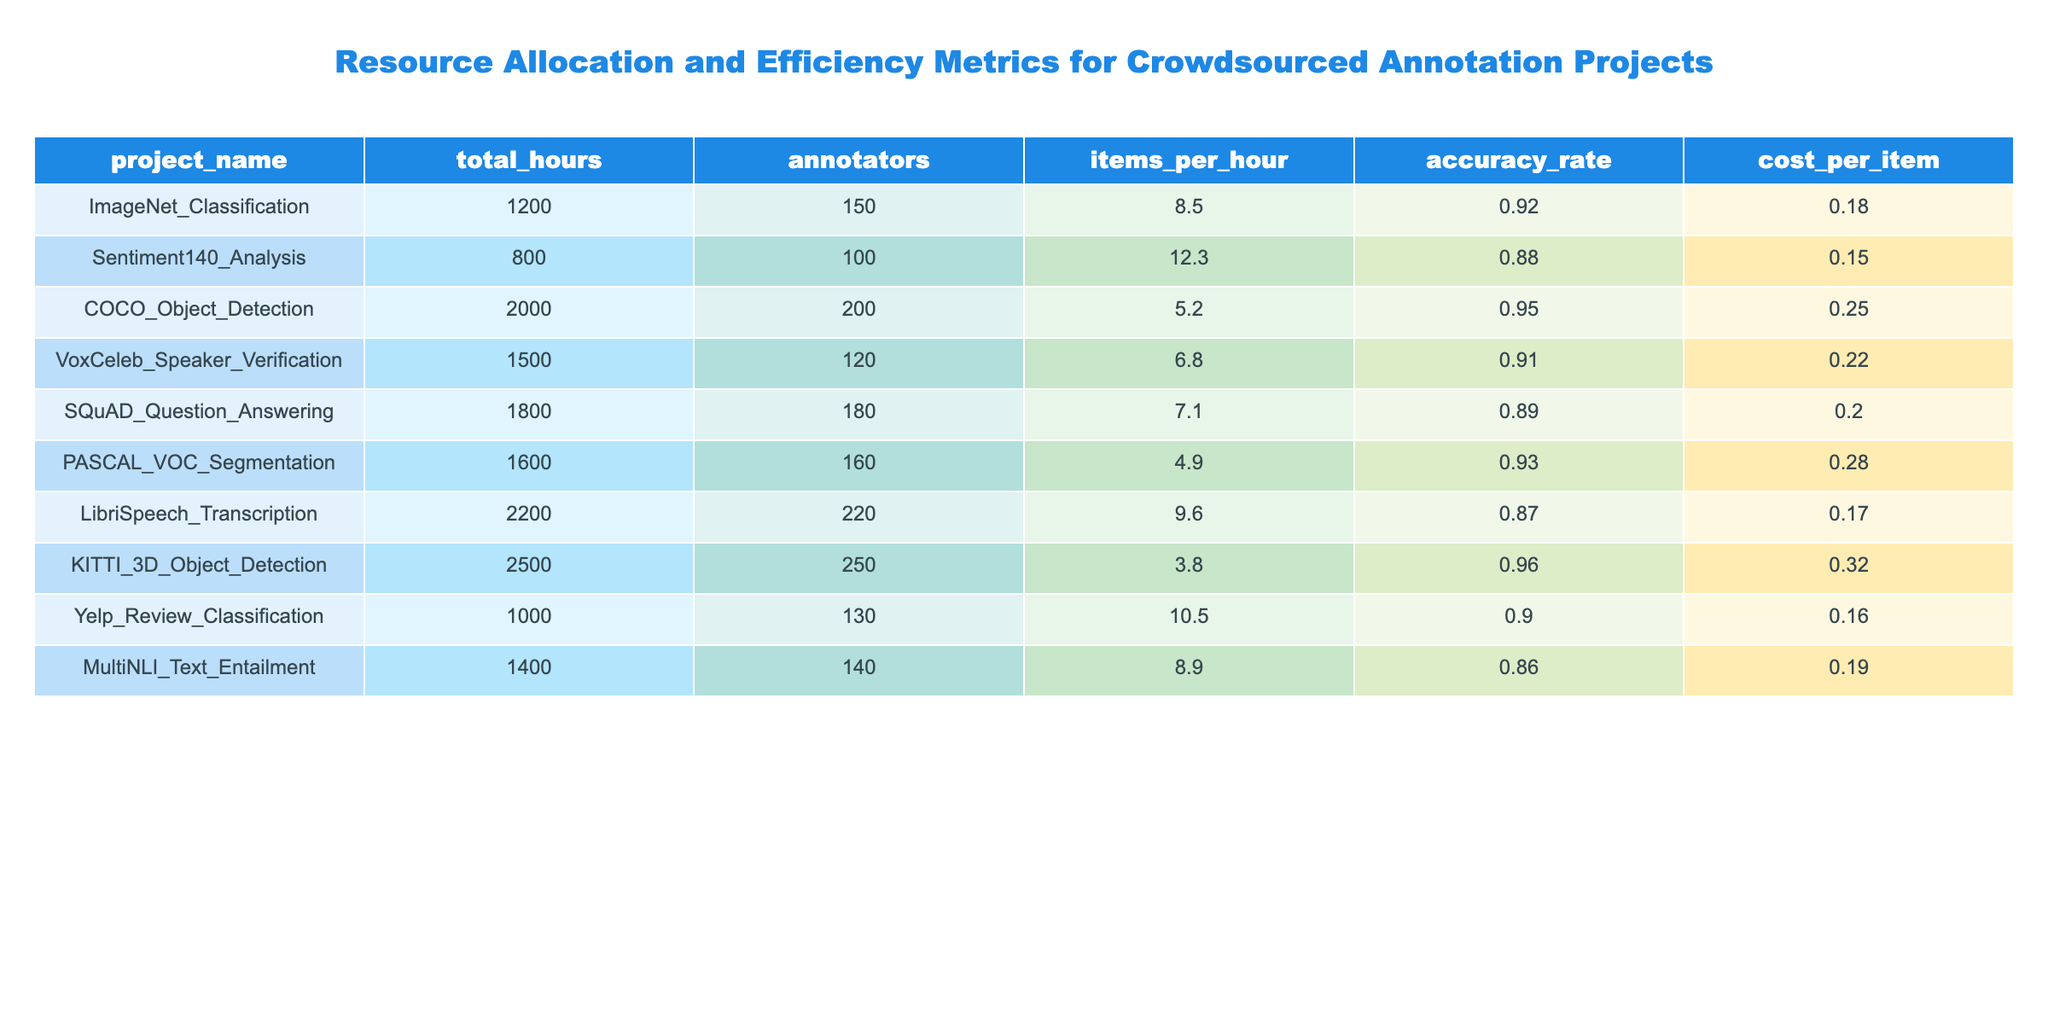What is the total number of annotators for the COCO_Object_Detection project? In the table, the column for annotators shows that COCO_Object_Detection has 200 annotators.
Answer: 200 Which project has the highest accuracy rate? Looking at the accuracy rate column, KITTI_3D_Object_Detection has the highest accuracy at 0.96.
Answer: KITTI_3D_Object_Detection What is the cost per item for the SQuAD_Question_Answering project? By checking the cost_per_item column, we find that SQuAD_Question_Answering costs 0.20 per item.
Answer: 0.20 Calculate the average items processed per hour across all projects. To find the average, sum the items_per_hour for all projects: (8.5 + 12.3 + 5.2 + 6.8 + 7.1 + 4.9 + 9.6 + 3.8 + 10.5 + 8.9) = 67.1; there are 10 projects, so the average is 67.1 / 10 = 6.71.
Answer: 6.71 Which project requires the least total hours? By examining the total_hours column, Sentiment140_Analysis has the lowest total hours at 800.
Answer: Sentiment140_Analysis Is the cost per item for the LibriSpeech_Transcription project lower than the cost per item for the PASCAL_VOC_Segmentation project? The cost per item for LibriSpeech_Transcription is 0.17, while for PASCAL_VOC_Segmentation it is 0.28; since 0.17 is less than 0.28, the statement is true.
Answer: Yes Determine the difference in total hours between the KITTI_3D_Object_Detection and the ImageNet_Classification projects. Total hours for KITTI_3D_Object_Detection is 2500 and for ImageNet_Classification is 1200. The difference is 2500 - 1200 = 1300.
Answer: 1300 If we consider only the projects with more than 150 annotators, what is the average accuracy rate for these projects? The projects with more than 150 annotators are COCO_Object_Detection, LibriSpeech_Transcription, and KITTI_3D_Object_Detection with accuracy rates of 0.95, 0.87, and 0.96 respectively. The average is (0.95 + 0.87 + 0.96) / 3 = 0.93.
Answer: 0.93 What is the total cost for all items in the Yelps_Review_Classification project? The total cost can be calculated as cost_per_item multiplied by total_hours. The number of items can be calculated as total_hours multiplied by items_per_hour, thus total cost = (1000 hours * 10.5 items/hour) * 0.16 = 1680.
Answer: 1680 Which project has the highest cost per item? Upon reviewing the cost_per_item column, KITTI_3D_Object_Detection has the highest cost per item at 0.32.
Answer: KITTI_3D_Object_Detection 